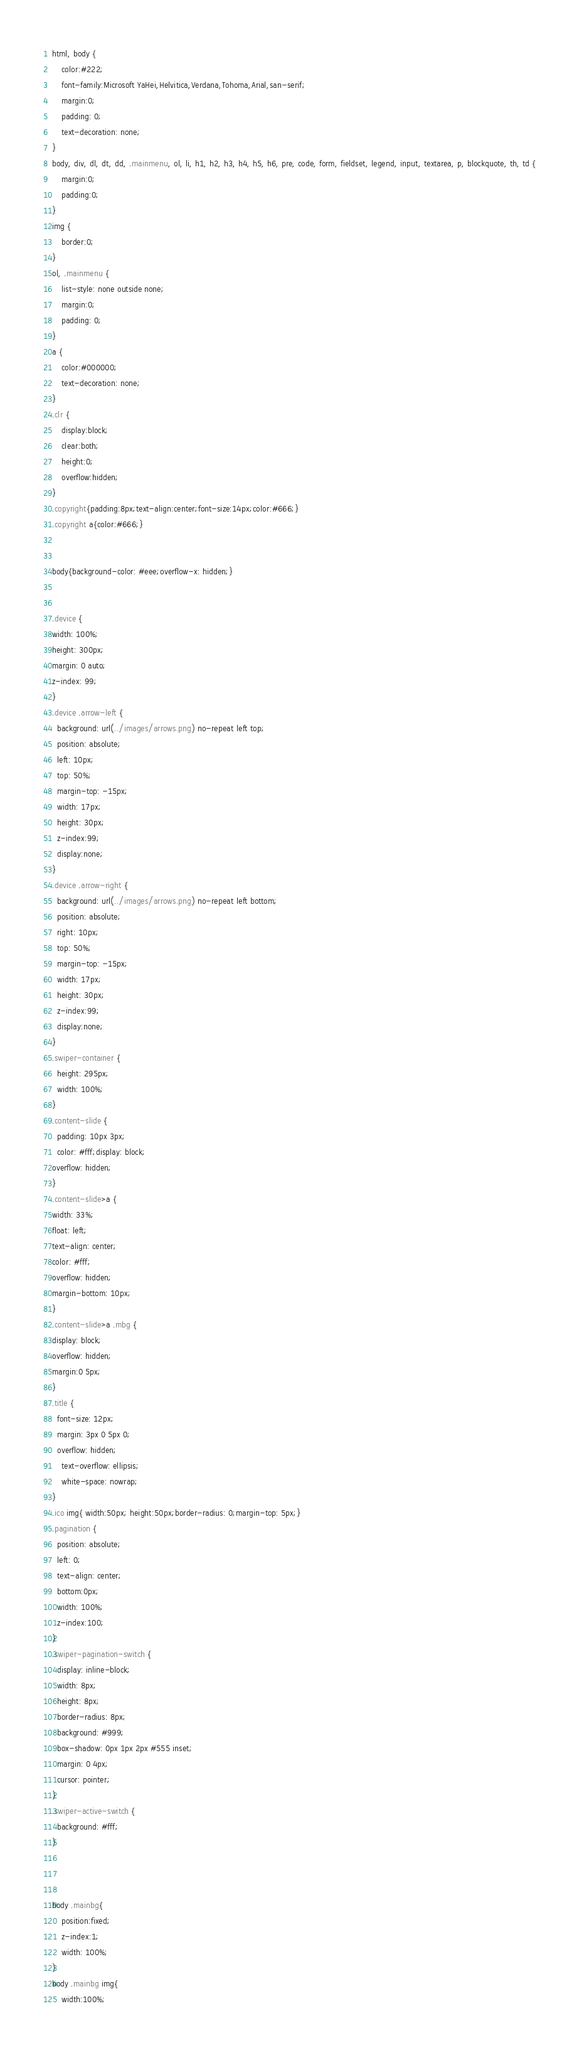<code> <loc_0><loc_0><loc_500><loc_500><_CSS_>html, body {
	color:#222;
	font-family:Microsoft YaHei,Helvitica,Verdana,Tohoma,Arial,san-serif;
	margin:0;
	padding: 0;
	text-decoration: none;
}
body, div, dl, dt, dd, .mainmenu, ol, li, h1, h2, h3, h4, h5, h6, pre, code, form, fieldset, legend, input, textarea, p, blockquote, th, td {
	margin:0;
	padding:0;
}
img {
	border:0;
}
ol, .mainmenu {
	list-style: none outside none;
	margin:0;
	padding: 0;
}
a {
	color:#000000;
	text-decoration: none;
}
.clr {
	display:block;
	clear:both;
	height:0;
	overflow:hidden;
}
.copyright{padding:8px;text-align:center;font-size:14px;color:#666;}
.copyright a{color:#666;}


body{background-color: #eee;overflow-x: hidden;}


.device {
width: 100%;
height: 300px;
margin: 0 auto;
z-index: 99;
}
.device .arrow-left {
  background: url(../images/arrows.png) no-repeat left top;
  position: absolute;
  left: 10px;
  top: 50%;
  margin-top: -15px;
  width: 17px;
  height: 30px;
  z-index:99;
  display:none;
}
.device .arrow-right {
  background: url(../images/arrows.png) no-repeat left bottom;
  position: absolute;
  right: 10px;
  top: 50%;
  margin-top: -15px;
  width: 17px;
  height: 30px;
  z-index:99;
  display:none;
}
.swiper-container {
  height: 295px;
  width: 100%;
}
.content-slide {
  padding: 10px 3px;
  color: #fff;display: block;
overflow: hidden;
}
.content-slide>a {
width: 33%;
float: left;
text-align: center;
color: #fff;
overflow: hidden;
margin-bottom: 10px;
}
.content-slide>a .mbg {
display: block;
overflow: hidden;
margin:0 5px;
}
.title {
  font-size: 12px;
  margin: 3px 0 5px 0;
  overflow: hidden;
	text-overflow: ellipsis;
	white-space: nowrap;
}
.ico img{ width:50px; height:50px;border-radius: 0;margin-top: 5px;}
.pagination {
  position: absolute;
  left: 0;
  text-align: center;
  bottom:0px;
  width: 100%;
  z-index:100;
}
.swiper-pagination-switch {
  display: inline-block;
  width: 8px;
  height: 8px;
  border-radius: 8px;
  background: #999;
  box-shadow: 0px 1px 2px #555 inset;
  margin: 0 4px;
  cursor: pointer;
}
.swiper-active-switch {
  background: #fff;
}



body .mainbg{ 
	position:fixed;
	z-index:1;
	width: 100%;
}
body .mainbg img{
	width:100%;</code> 